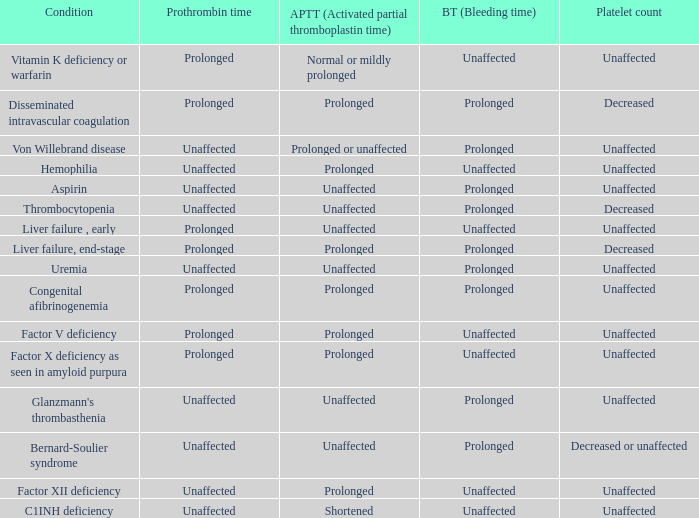Which partial thromboplastin time has a condition of liver failure , early? Unaffected. 